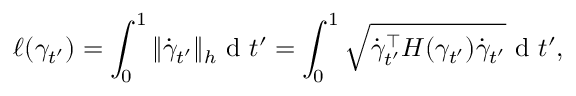<formula> <loc_0><loc_0><loc_500><loc_500>\ell ( \gamma _ { t ^ { \prime } } ) = \int _ { 0 } ^ { 1 } \| \dot { \gamma } _ { t ^ { \prime } } \| _ { h } d t ^ { \prime } = \int _ { 0 } ^ { 1 } \sqrt { \dot { \gamma } _ { t ^ { \prime } } ^ { \top } H ( \gamma _ { t ^ { \prime } } ) \dot { \gamma } _ { t ^ { \prime } } } d t ^ { \prime } ,</formula> 